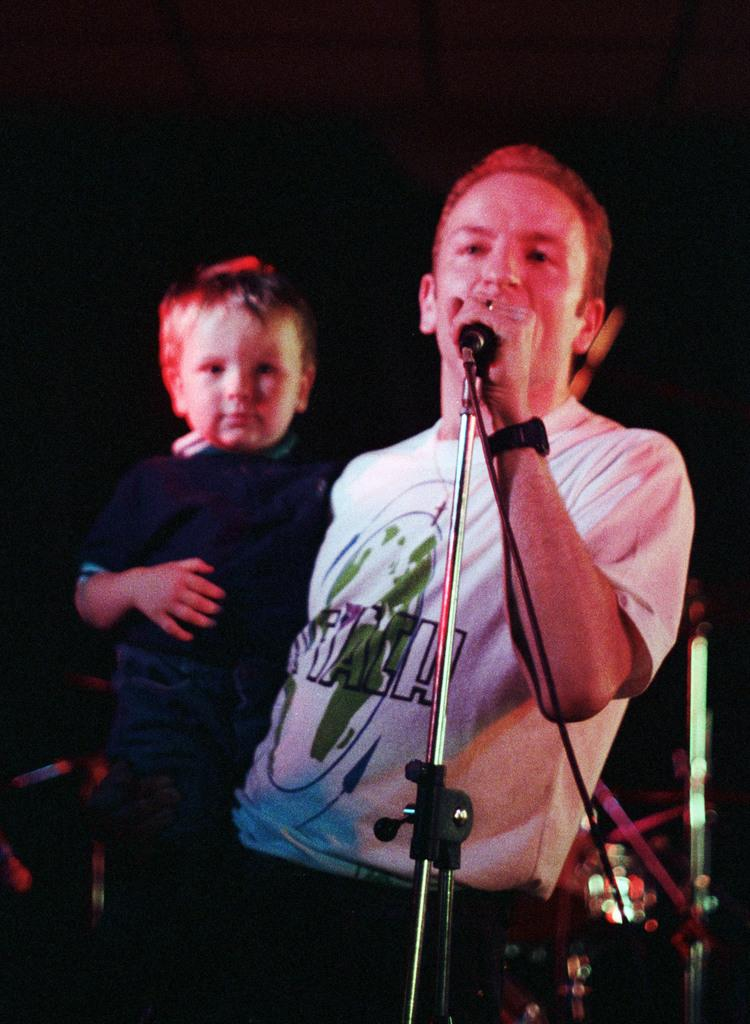Who is present in the image? There is a man and a kid in the image. What is the man holding in the image? The man is holding a microphone. What can be observed about the background of the image? The background of the image is dark. What type of quartz can be seen in the image? There is no quartz present in the image. How many nails are visible in the image? There are no nails visible in the image. 